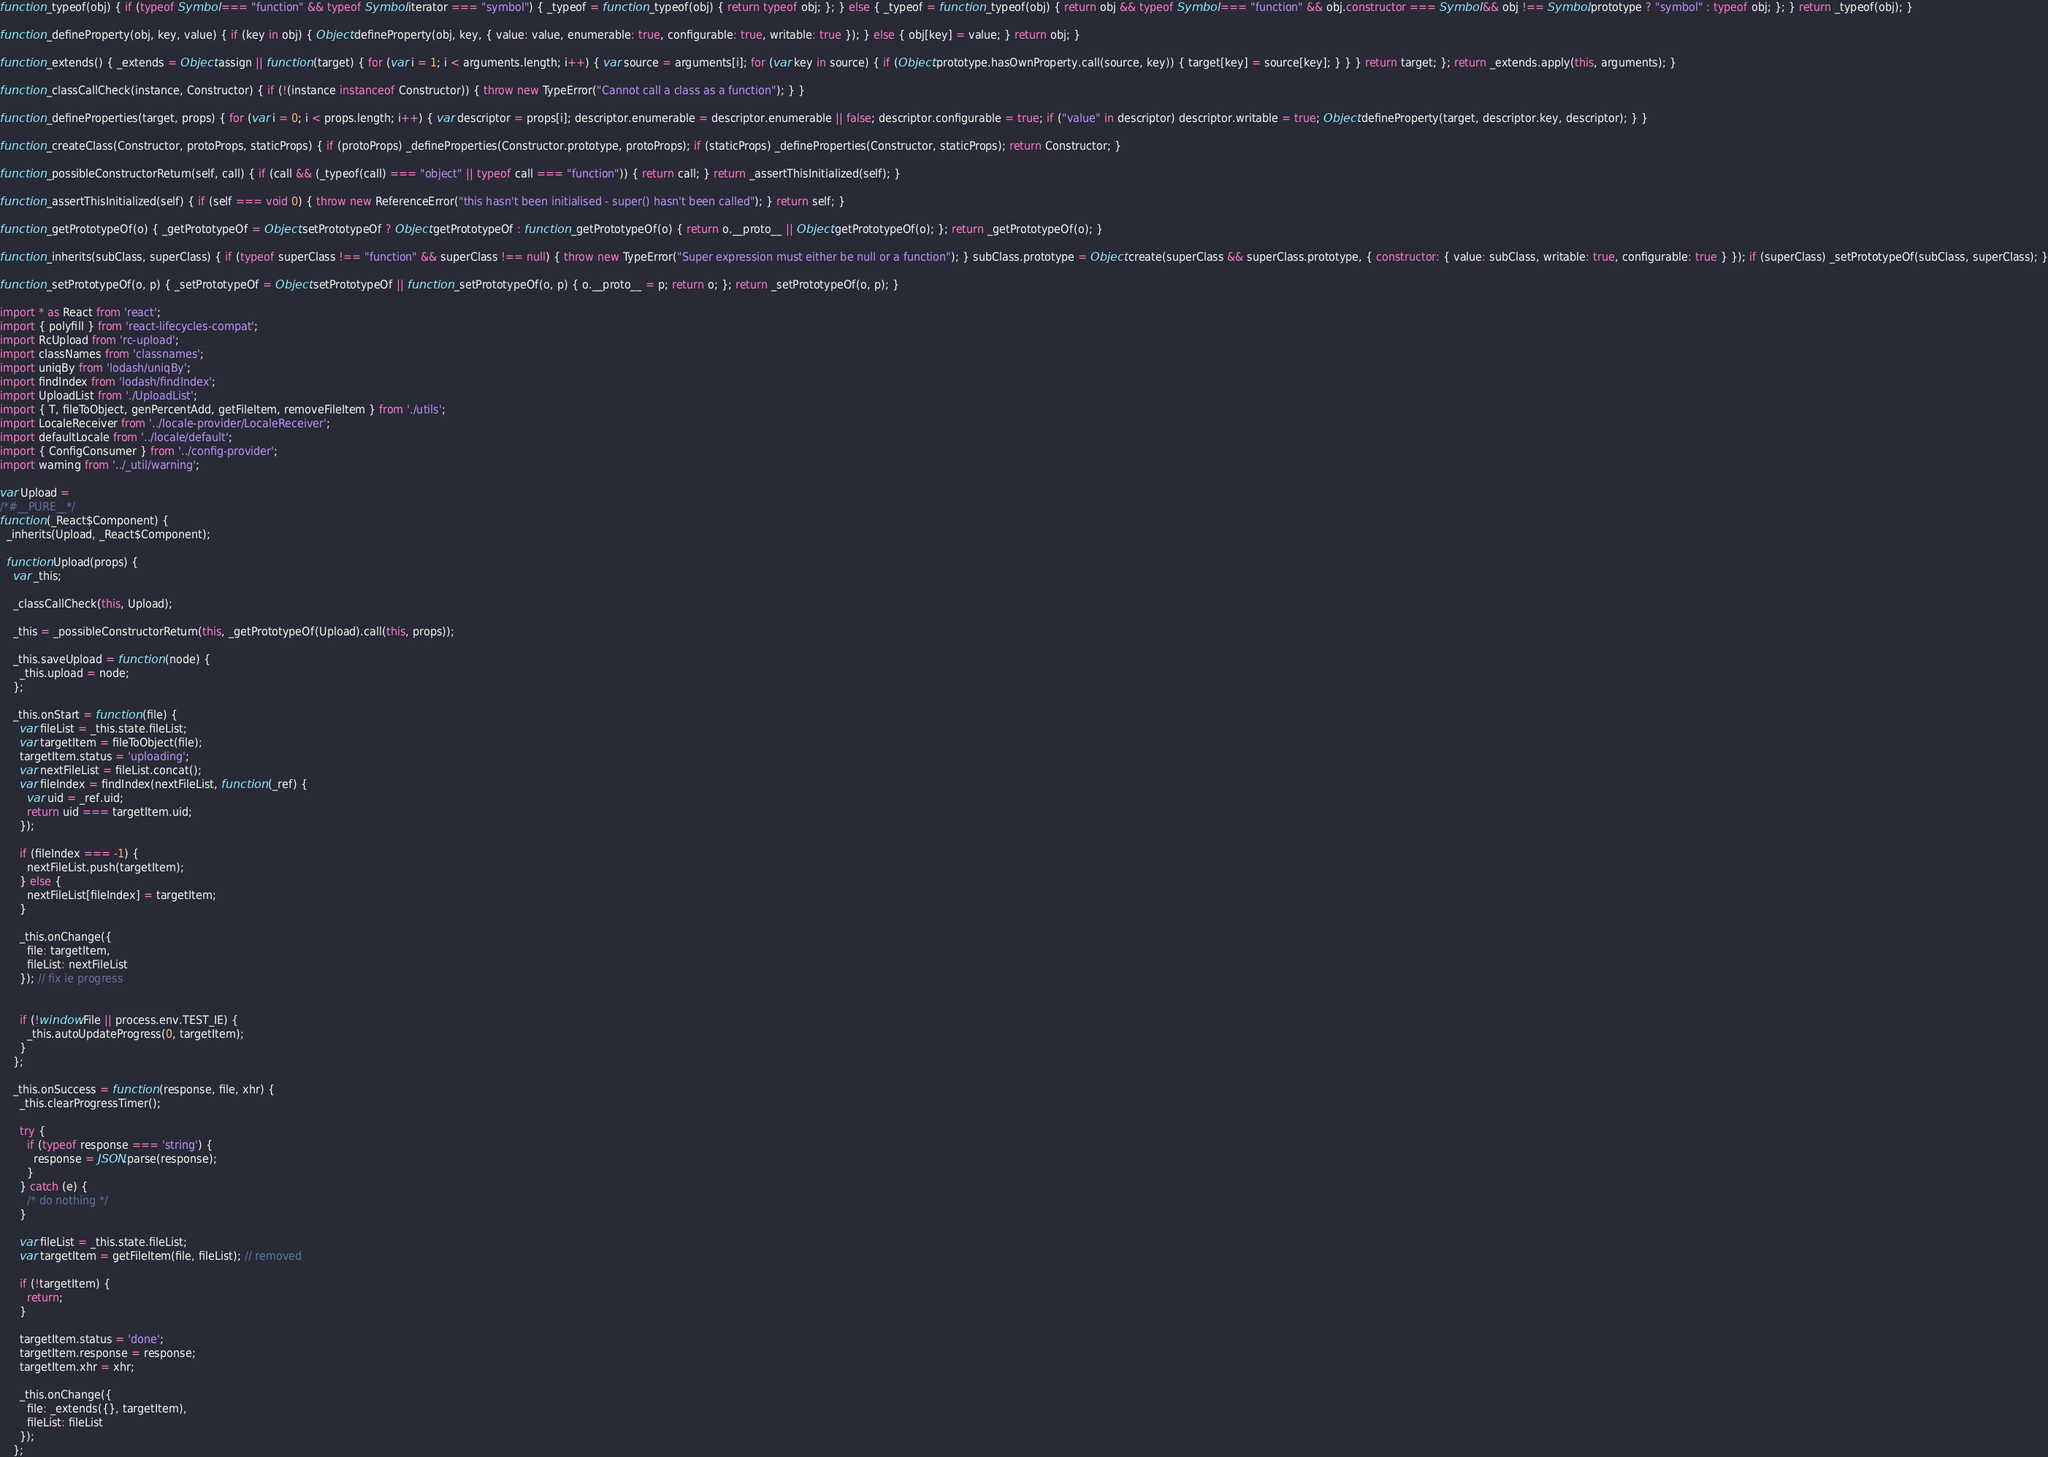Convert code to text. <code><loc_0><loc_0><loc_500><loc_500><_JavaScript_>function _typeof(obj) { if (typeof Symbol === "function" && typeof Symbol.iterator === "symbol") { _typeof = function _typeof(obj) { return typeof obj; }; } else { _typeof = function _typeof(obj) { return obj && typeof Symbol === "function" && obj.constructor === Symbol && obj !== Symbol.prototype ? "symbol" : typeof obj; }; } return _typeof(obj); }

function _defineProperty(obj, key, value) { if (key in obj) { Object.defineProperty(obj, key, { value: value, enumerable: true, configurable: true, writable: true }); } else { obj[key] = value; } return obj; }

function _extends() { _extends = Object.assign || function (target) { for (var i = 1; i < arguments.length; i++) { var source = arguments[i]; for (var key in source) { if (Object.prototype.hasOwnProperty.call(source, key)) { target[key] = source[key]; } } } return target; }; return _extends.apply(this, arguments); }

function _classCallCheck(instance, Constructor) { if (!(instance instanceof Constructor)) { throw new TypeError("Cannot call a class as a function"); } }

function _defineProperties(target, props) { for (var i = 0; i < props.length; i++) { var descriptor = props[i]; descriptor.enumerable = descriptor.enumerable || false; descriptor.configurable = true; if ("value" in descriptor) descriptor.writable = true; Object.defineProperty(target, descriptor.key, descriptor); } }

function _createClass(Constructor, protoProps, staticProps) { if (protoProps) _defineProperties(Constructor.prototype, protoProps); if (staticProps) _defineProperties(Constructor, staticProps); return Constructor; }

function _possibleConstructorReturn(self, call) { if (call && (_typeof(call) === "object" || typeof call === "function")) { return call; } return _assertThisInitialized(self); }

function _assertThisInitialized(self) { if (self === void 0) { throw new ReferenceError("this hasn't been initialised - super() hasn't been called"); } return self; }

function _getPrototypeOf(o) { _getPrototypeOf = Object.setPrototypeOf ? Object.getPrototypeOf : function _getPrototypeOf(o) { return o.__proto__ || Object.getPrototypeOf(o); }; return _getPrototypeOf(o); }

function _inherits(subClass, superClass) { if (typeof superClass !== "function" && superClass !== null) { throw new TypeError("Super expression must either be null or a function"); } subClass.prototype = Object.create(superClass && superClass.prototype, { constructor: { value: subClass, writable: true, configurable: true } }); if (superClass) _setPrototypeOf(subClass, superClass); }

function _setPrototypeOf(o, p) { _setPrototypeOf = Object.setPrototypeOf || function _setPrototypeOf(o, p) { o.__proto__ = p; return o; }; return _setPrototypeOf(o, p); }

import * as React from 'react';
import { polyfill } from 'react-lifecycles-compat';
import RcUpload from 'rc-upload';
import classNames from 'classnames';
import uniqBy from 'lodash/uniqBy';
import findIndex from 'lodash/findIndex';
import UploadList from './UploadList';
import { T, fileToObject, genPercentAdd, getFileItem, removeFileItem } from './utils';
import LocaleReceiver from '../locale-provider/LocaleReceiver';
import defaultLocale from '../locale/default';
import { ConfigConsumer } from '../config-provider';
import warning from '../_util/warning';

var Upload =
/*#__PURE__*/
function (_React$Component) {
  _inherits(Upload, _React$Component);

  function Upload(props) {
    var _this;

    _classCallCheck(this, Upload);

    _this = _possibleConstructorReturn(this, _getPrototypeOf(Upload).call(this, props));

    _this.saveUpload = function (node) {
      _this.upload = node;
    };

    _this.onStart = function (file) {
      var fileList = _this.state.fileList;
      var targetItem = fileToObject(file);
      targetItem.status = 'uploading';
      var nextFileList = fileList.concat();
      var fileIndex = findIndex(nextFileList, function (_ref) {
        var uid = _ref.uid;
        return uid === targetItem.uid;
      });

      if (fileIndex === -1) {
        nextFileList.push(targetItem);
      } else {
        nextFileList[fileIndex] = targetItem;
      }

      _this.onChange({
        file: targetItem,
        fileList: nextFileList
      }); // fix ie progress


      if (!window.File || process.env.TEST_IE) {
        _this.autoUpdateProgress(0, targetItem);
      }
    };

    _this.onSuccess = function (response, file, xhr) {
      _this.clearProgressTimer();

      try {
        if (typeof response === 'string') {
          response = JSON.parse(response);
        }
      } catch (e) {
        /* do nothing */
      }

      var fileList = _this.state.fileList;
      var targetItem = getFileItem(file, fileList); // removed

      if (!targetItem) {
        return;
      }

      targetItem.status = 'done';
      targetItem.response = response;
      targetItem.xhr = xhr;

      _this.onChange({
        file: _extends({}, targetItem),
        fileList: fileList
      });
    };
</code> 